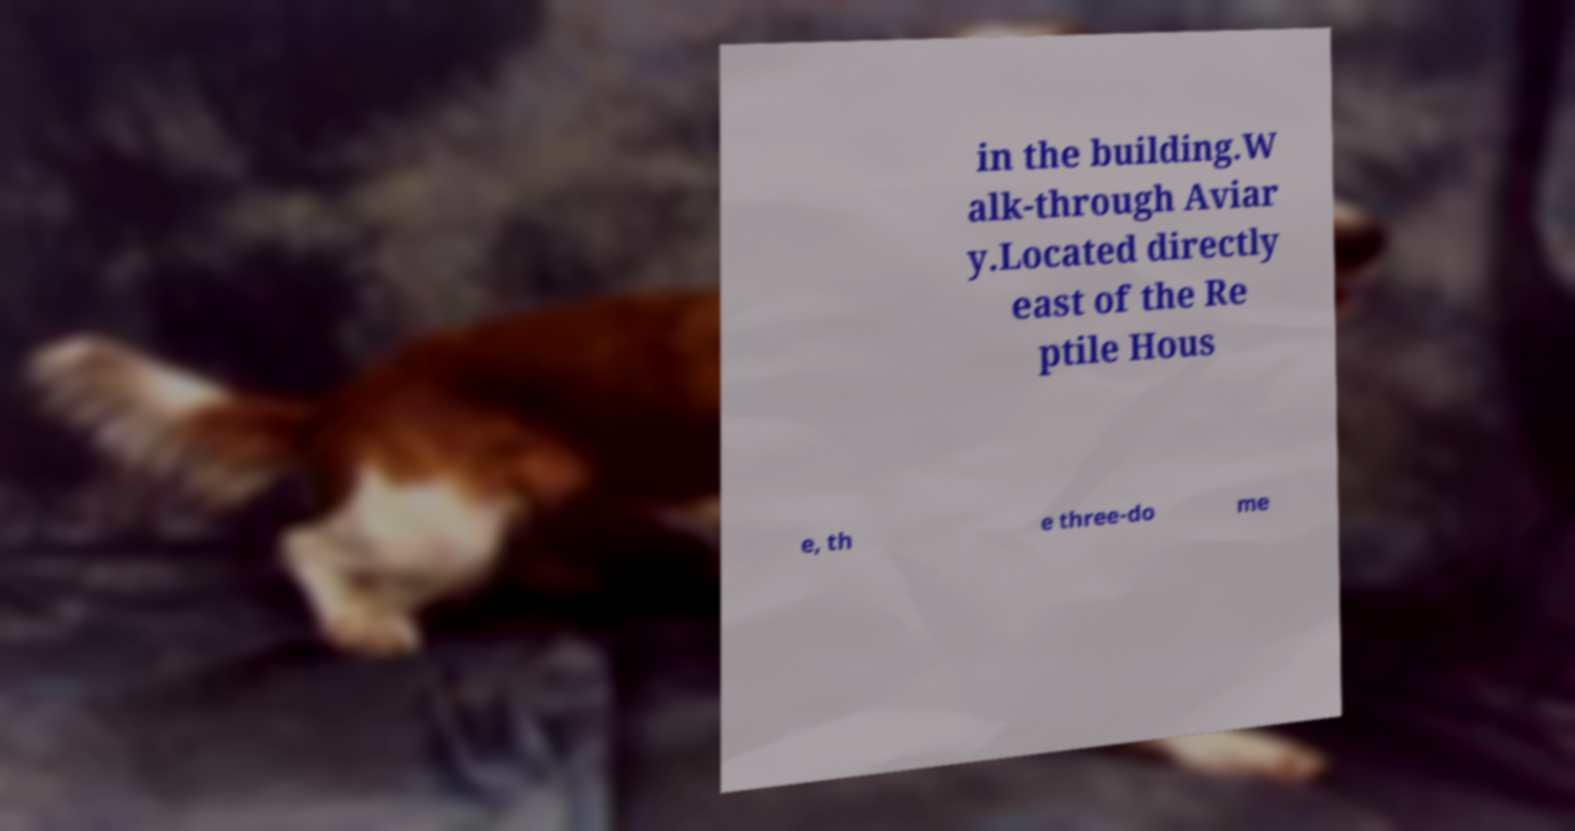For documentation purposes, I need the text within this image transcribed. Could you provide that? in the building.W alk-through Aviar y.Located directly east of the Re ptile Hous e, th e three-do me 